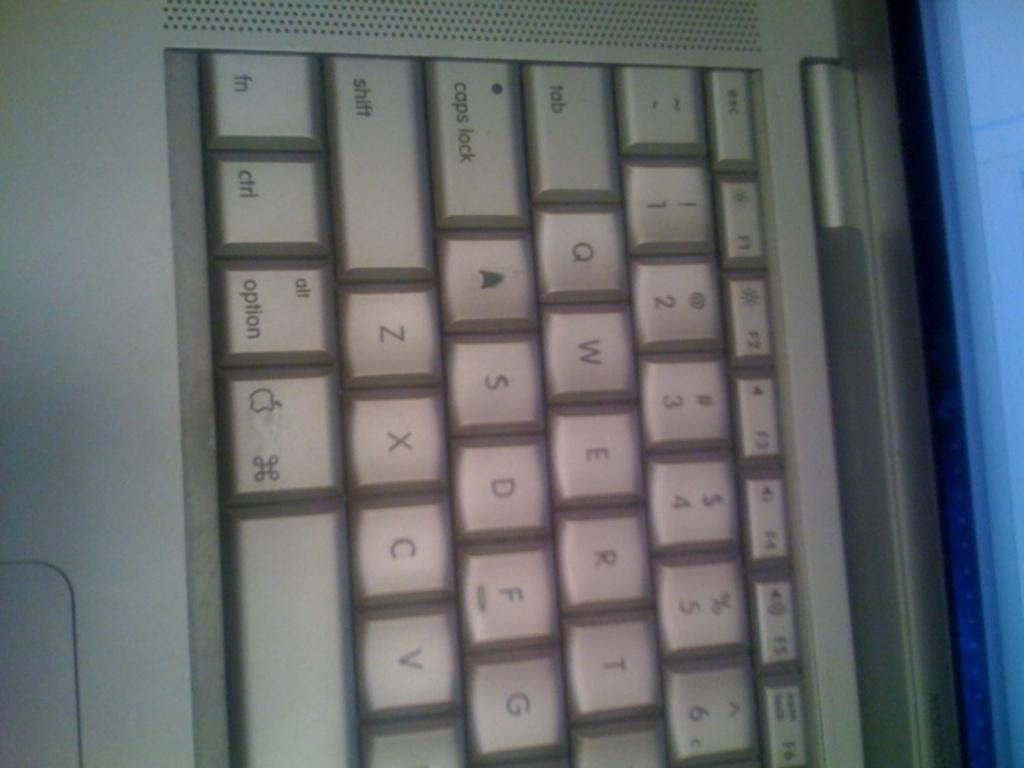<image>
Share a concise interpretation of the image provided. A closeup of an Apple keyboard showing buttons like caps lock and ctrl. 